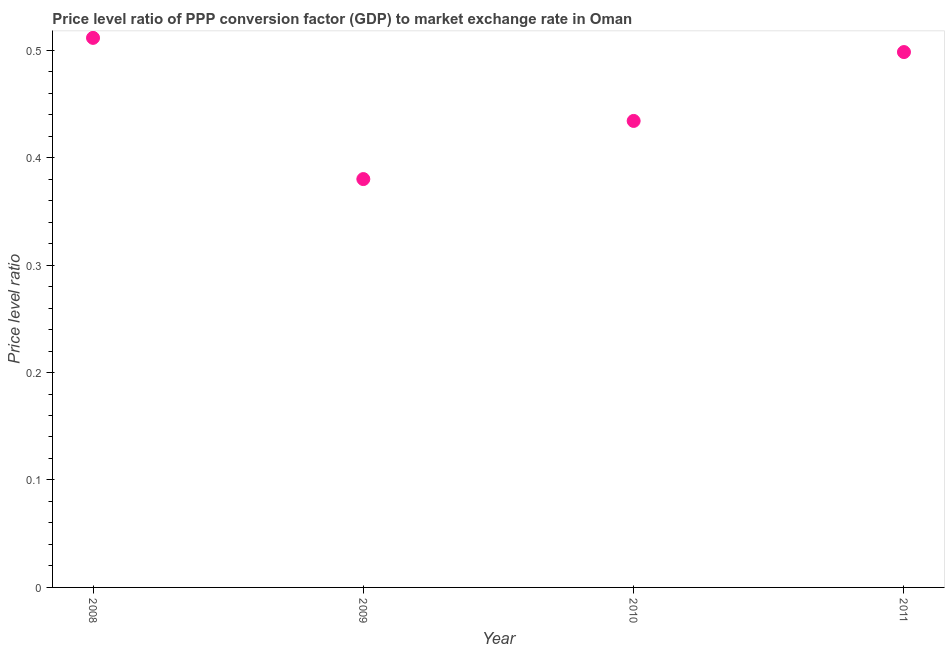What is the price level ratio in 2010?
Your response must be concise. 0.43. Across all years, what is the maximum price level ratio?
Give a very brief answer. 0.51. Across all years, what is the minimum price level ratio?
Provide a short and direct response. 0.38. In which year was the price level ratio maximum?
Your response must be concise. 2008. What is the sum of the price level ratio?
Offer a terse response. 1.82. What is the difference between the price level ratio in 2009 and 2010?
Offer a terse response. -0.05. What is the average price level ratio per year?
Give a very brief answer. 0.46. What is the median price level ratio?
Keep it short and to the point. 0.47. In how many years, is the price level ratio greater than 0.2 ?
Keep it short and to the point. 4. Do a majority of the years between 2011 and 2008 (inclusive) have price level ratio greater than 0.48000000000000004 ?
Provide a succinct answer. Yes. What is the ratio of the price level ratio in 2008 to that in 2009?
Ensure brevity in your answer.  1.35. Is the price level ratio in 2009 less than that in 2011?
Your answer should be very brief. Yes. What is the difference between the highest and the second highest price level ratio?
Provide a succinct answer. 0.01. Is the sum of the price level ratio in 2009 and 2010 greater than the maximum price level ratio across all years?
Provide a short and direct response. Yes. What is the difference between the highest and the lowest price level ratio?
Keep it short and to the point. 0.13. Does the price level ratio monotonically increase over the years?
Offer a terse response. No. How many years are there in the graph?
Your answer should be very brief. 4. What is the difference between two consecutive major ticks on the Y-axis?
Offer a terse response. 0.1. Are the values on the major ticks of Y-axis written in scientific E-notation?
Provide a short and direct response. No. Does the graph contain any zero values?
Make the answer very short. No. What is the title of the graph?
Give a very brief answer. Price level ratio of PPP conversion factor (GDP) to market exchange rate in Oman. What is the label or title of the X-axis?
Provide a short and direct response. Year. What is the label or title of the Y-axis?
Offer a very short reply. Price level ratio. What is the Price level ratio in 2008?
Give a very brief answer. 0.51. What is the Price level ratio in 2009?
Your answer should be compact. 0.38. What is the Price level ratio in 2010?
Offer a very short reply. 0.43. What is the Price level ratio in 2011?
Your answer should be very brief. 0.5. What is the difference between the Price level ratio in 2008 and 2009?
Keep it short and to the point. 0.13. What is the difference between the Price level ratio in 2008 and 2010?
Your answer should be compact. 0.08. What is the difference between the Price level ratio in 2008 and 2011?
Your answer should be very brief. 0.01. What is the difference between the Price level ratio in 2009 and 2010?
Provide a short and direct response. -0.05. What is the difference between the Price level ratio in 2009 and 2011?
Provide a succinct answer. -0.12. What is the difference between the Price level ratio in 2010 and 2011?
Your answer should be compact. -0.06. What is the ratio of the Price level ratio in 2008 to that in 2009?
Provide a succinct answer. 1.35. What is the ratio of the Price level ratio in 2008 to that in 2010?
Your response must be concise. 1.18. What is the ratio of the Price level ratio in 2009 to that in 2011?
Provide a succinct answer. 0.76. What is the ratio of the Price level ratio in 2010 to that in 2011?
Offer a terse response. 0.87. 